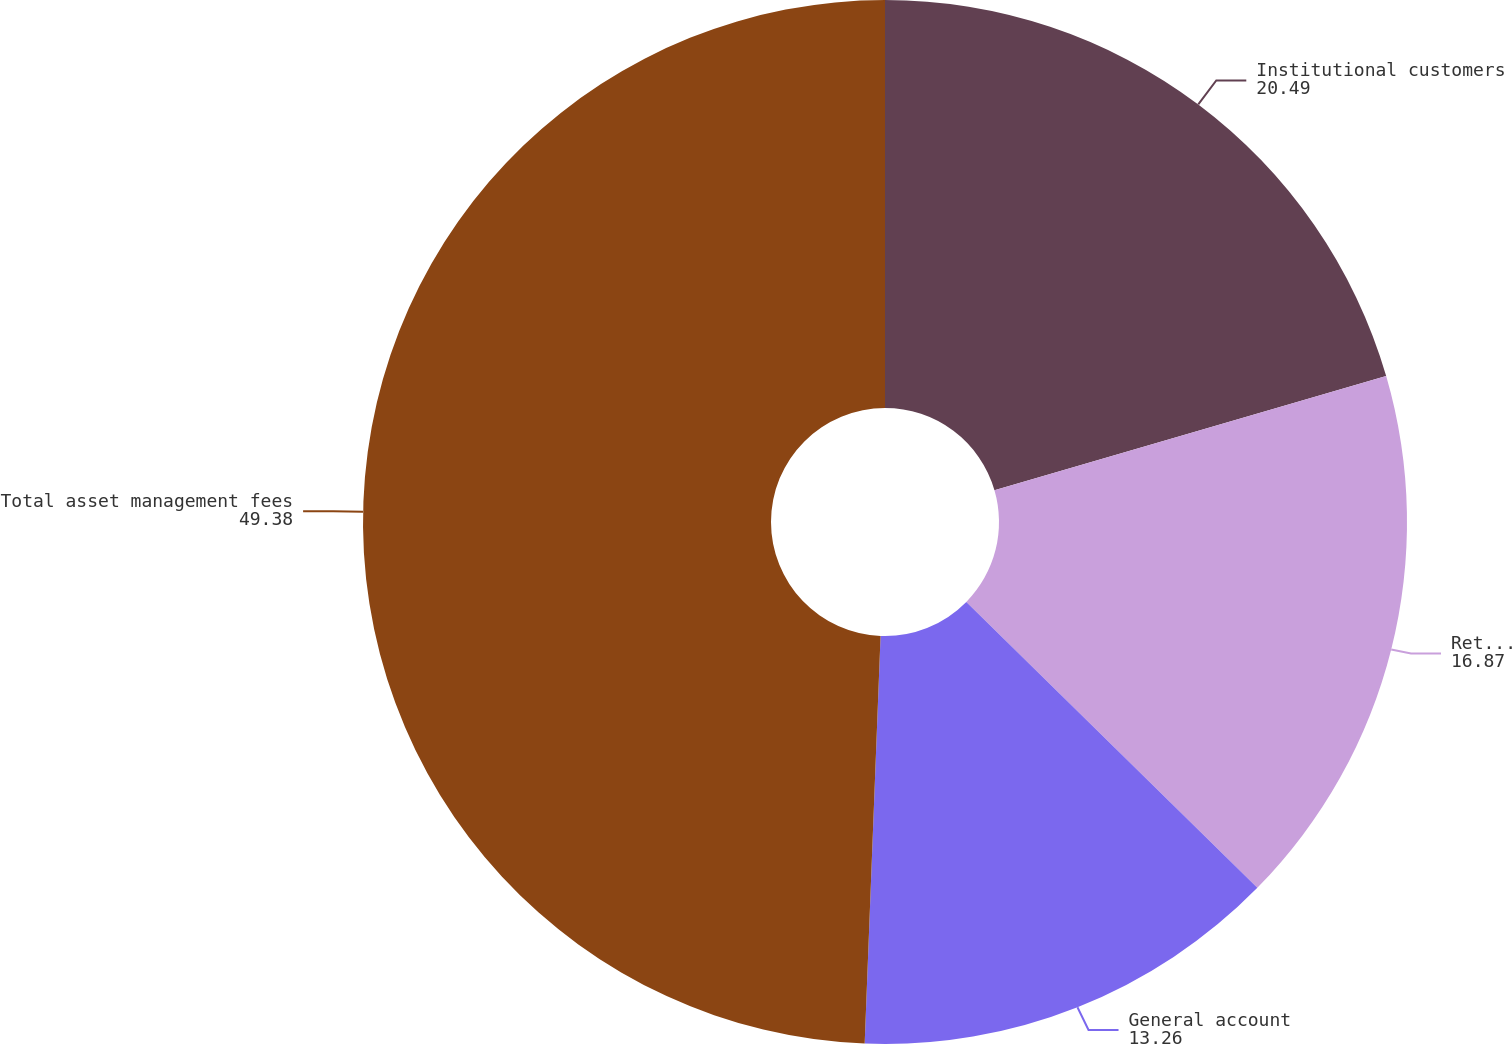Convert chart to OTSL. <chart><loc_0><loc_0><loc_500><loc_500><pie_chart><fcel>Institutional customers<fcel>Retail customers(1)<fcel>General account<fcel>Total asset management fees<nl><fcel>20.49%<fcel>16.87%<fcel>13.26%<fcel>49.38%<nl></chart> 